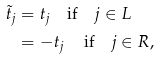Convert formula to latex. <formula><loc_0><loc_0><loc_500><loc_500>\tilde { t } _ { j } & = t _ { j } \quad \text {if} \quad j \in L \\ & = - t _ { j } \quad \, \text {if} \quad j \in R ,</formula> 